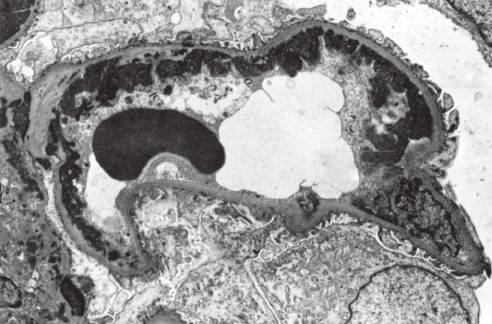what corresponds to wire loops seen by light microscopy?
Answer the question using a single word or phrase. Subendothelial dense deposits 